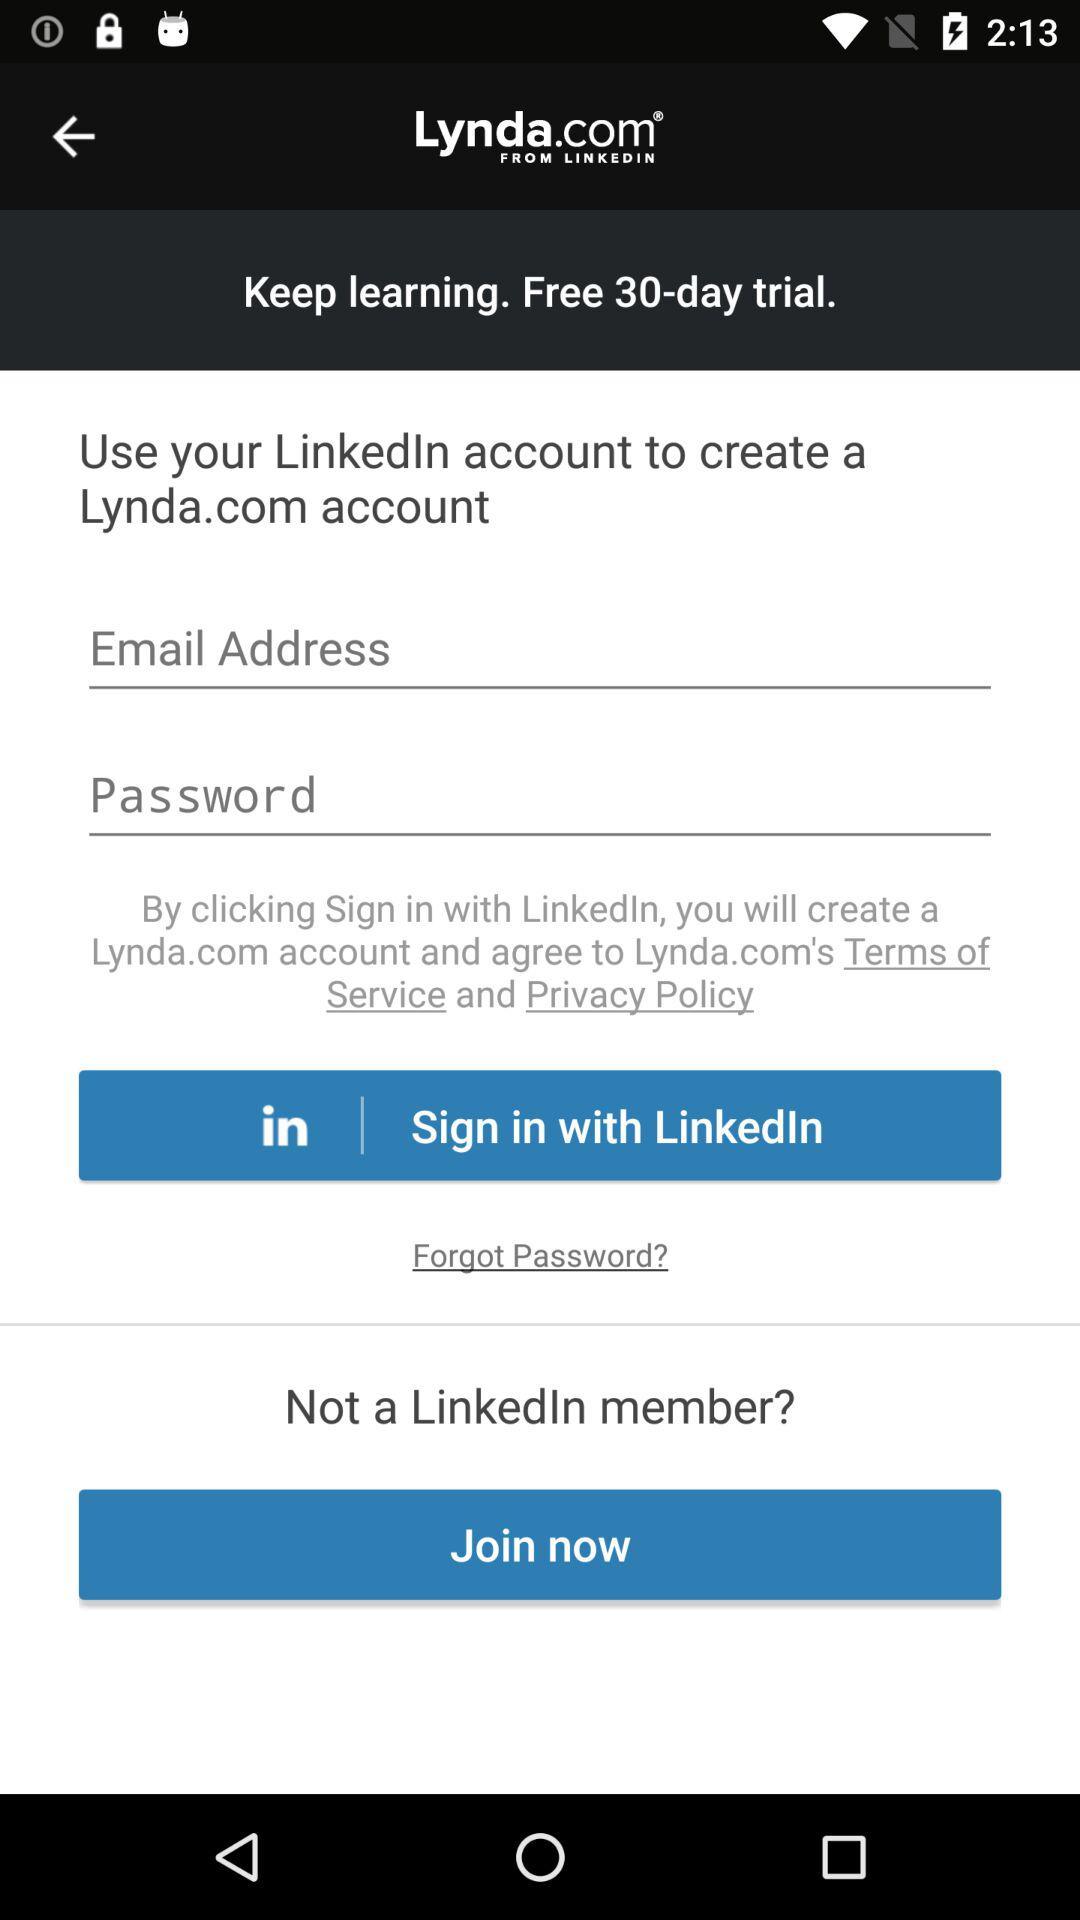For how many days is the free trial available? The free trial is available for 30 days. 